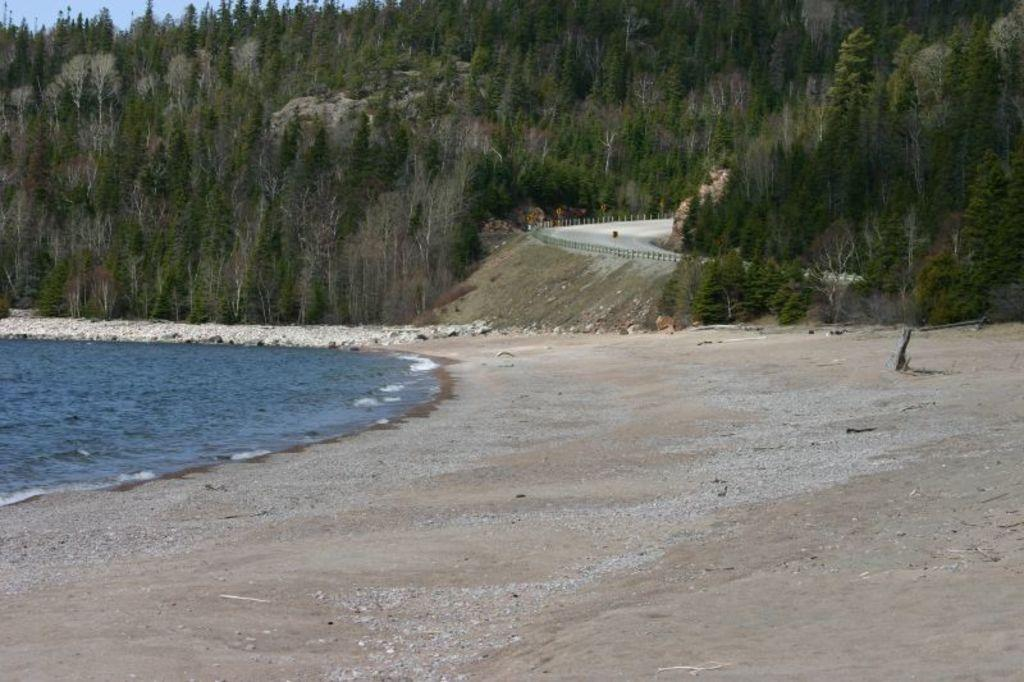What type of environment is shown in the image? The image depicts a sea with water, suggesting a coastal or seaside environment. Can you describe the location in the image? The location appears to be a seashore, as indicated by the presence of water and sand. What type of vegetation can be seen in the image? There are trees visible in the image. What is in the background of the image? There is a hill in the background. What man-made feature is present in the image? A road is present in the image. Where is the chicken's nest located in the image? There is no chicken or nest present in the image. What type of person can be seen walking on the hill in the image? There are no people visible in the image; only the sea, seashore, trees, hill, and road are present. 